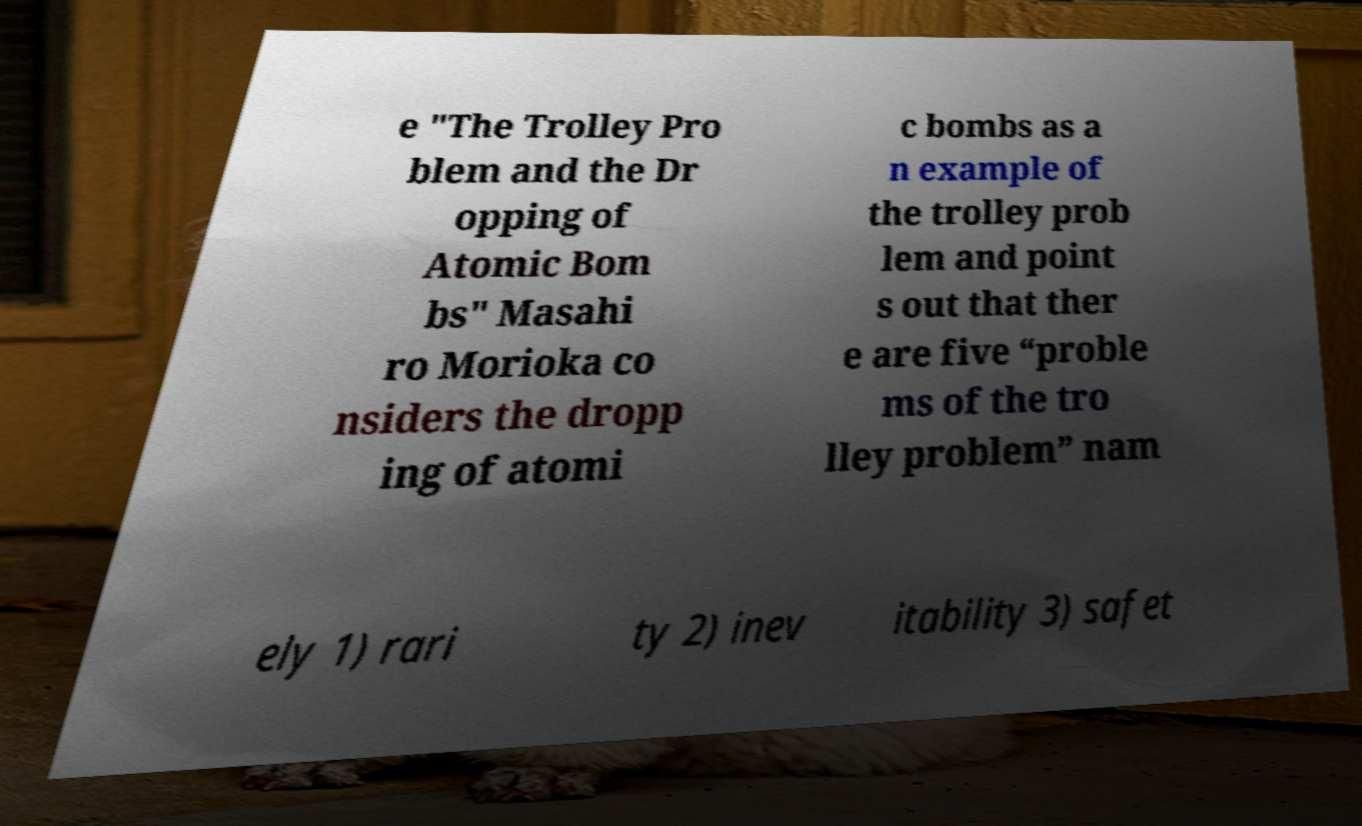What messages or text are displayed in this image? I need them in a readable, typed format. e "The Trolley Pro blem and the Dr opping of Atomic Bom bs" Masahi ro Morioka co nsiders the dropp ing of atomi c bombs as a n example of the trolley prob lem and point s out that ther e are five “proble ms of the tro lley problem” nam ely 1) rari ty 2) inev itability 3) safet 